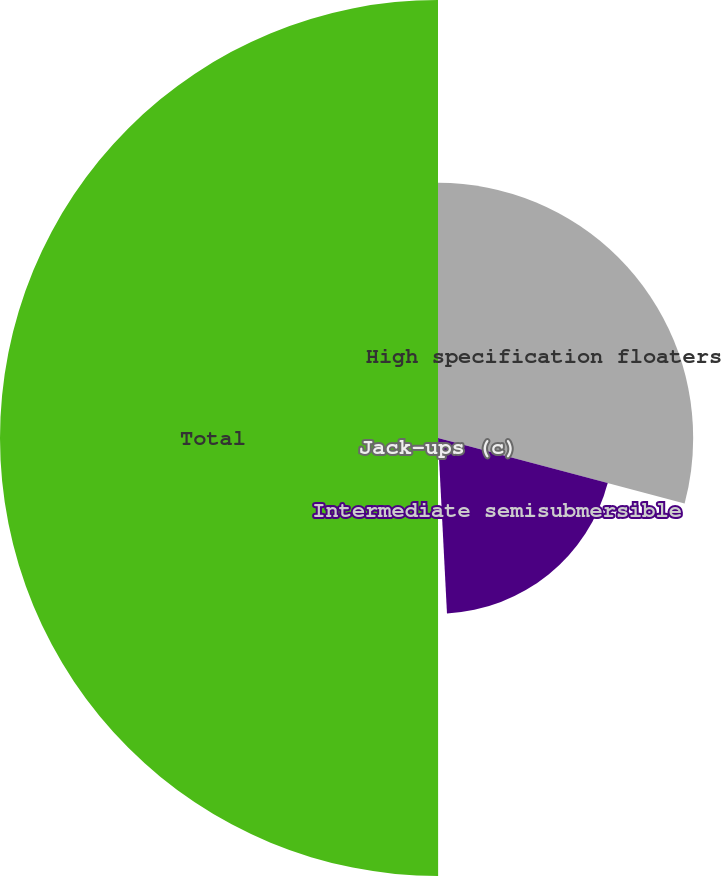<chart> <loc_0><loc_0><loc_500><loc_500><pie_chart><fcel>High specification floaters<fcel>Intermediate semisubmersible<fcel>Jack-ups (c)<fcel>Total<nl><fcel>29.13%<fcel>20.05%<fcel>0.81%<fcel>50.0%<nl></chart> 